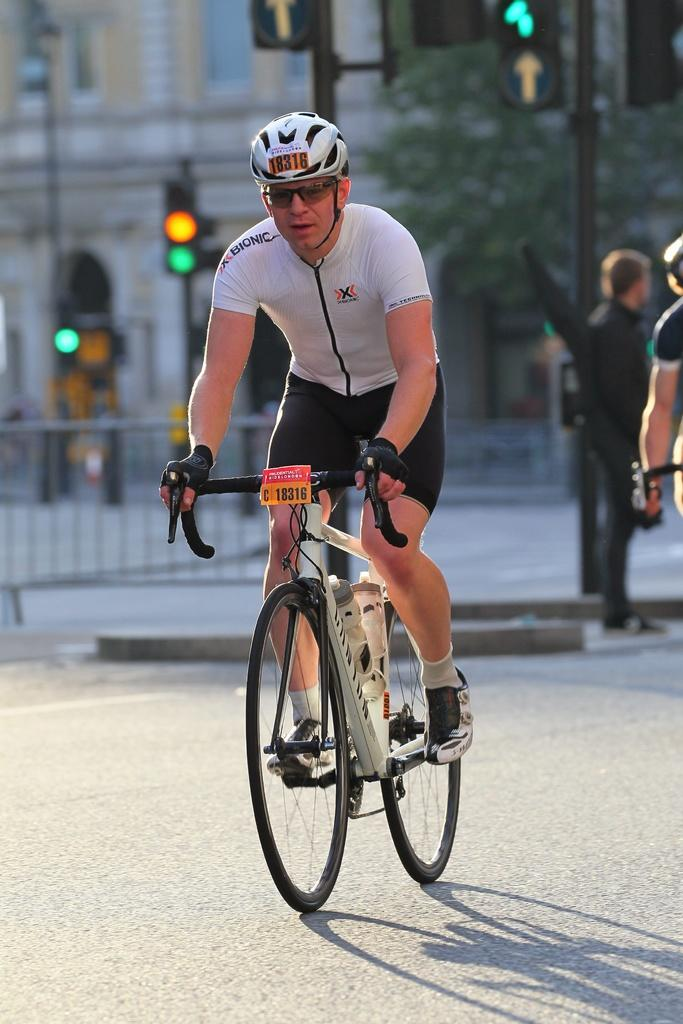What is the man in the image doing? The man is riding a bicycle in the image. What is the man wearing while riding the bicycle? The man is wearing a goggle and a helmet. Where is the man riding the bicycle? The bicycle is on a road. Can you describe the background of the image? In the background of the image, there is a fence, two persons, a pole, traffic lights, a building, and a tree. What type of grass can be seen growing in the alley behind the building in the image? There is no alley or grass present in the image. 